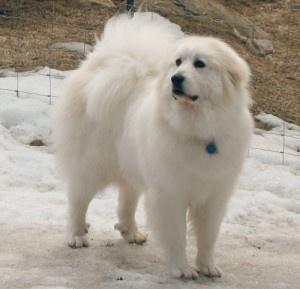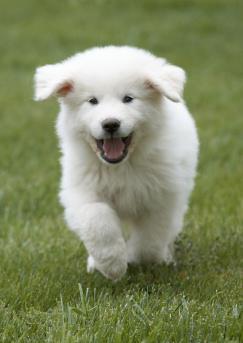The first image is the image on the left, the second image is the image on the right. Examine the images to the left and right. Is the description "There are two dogs" accurate? Answer yes or no. Yes. The first image is the image on the left, the second image is the image on the right. Examine the images to the left and right. Is the description "In total, only two fluffy dogs can be seen in these images." accurate? Answer yes or no. Yes. 